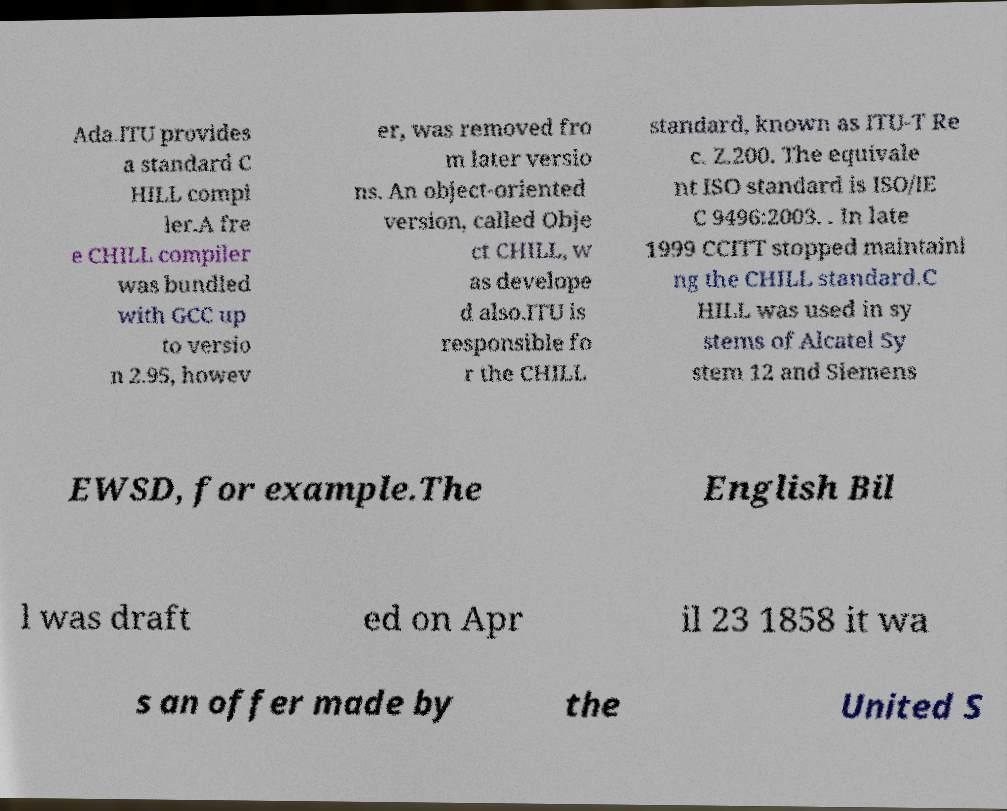I need the written content from this picture converted into text. Can you do that? Ada.ITU provides a standard C HILL compi ler.A fre e CHILL compiler was bundled with GCC up to versio n 2.95, howev er, was removed fro m later versio ns. An object-oriented version, called Obje ct CHILL, w as develope d also.ITU is responsible fo r the CHILL standard, known as ITU-T Re c. Z.200. The equivale nt ISO standard is ISO/IE C 9496:2003. . In late 1999 CCITT stopped maintaini ng the CHILL standard.C HILL was used in sy stems of Alcatel Sy stem 12 and Siemens EWSD, for example.The English Bil l was draft ed on Apr il 23 1858 it wa s an offer made by the United S 